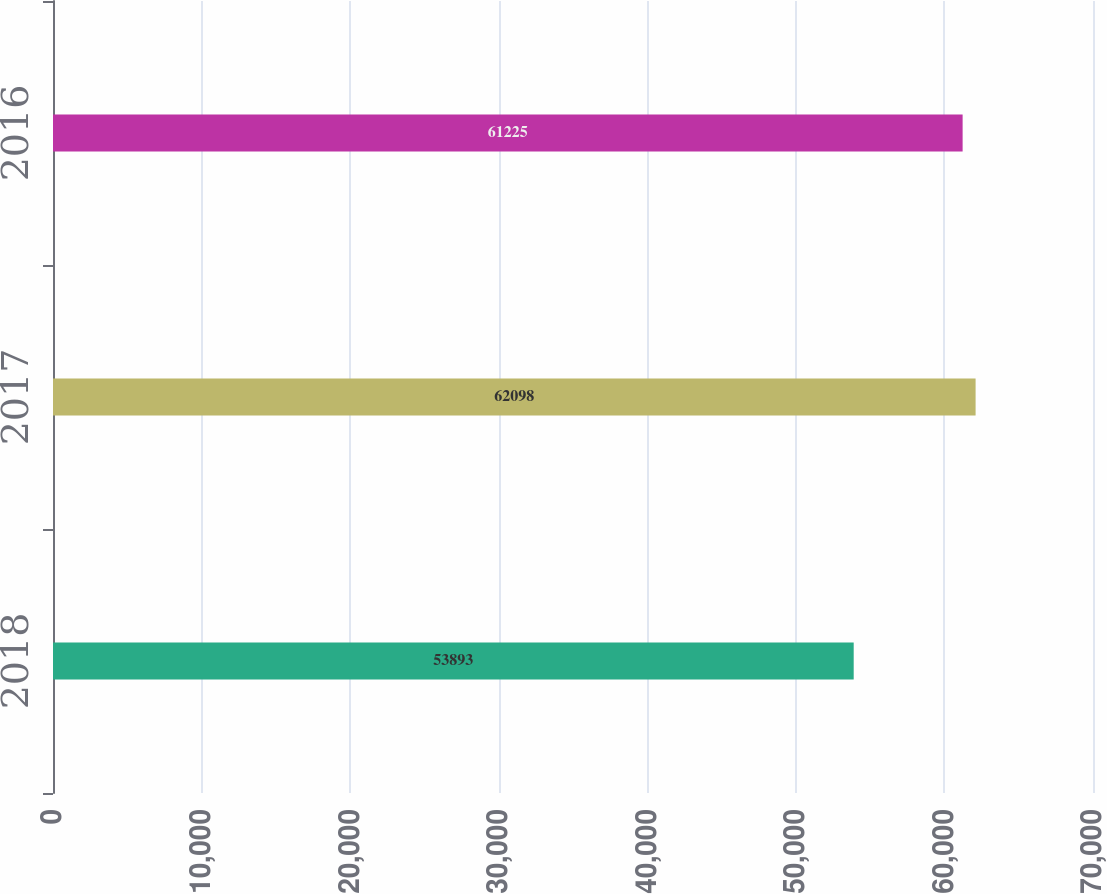Convert chart to OTSL. <chart><loc_0><loc_0><loc_500><loc_500><bar_chart><fcel>2018<fcel>2017<fcel>2016<nl><fcel>53893<fcel>62098<fcel>61225<nl></chart> 